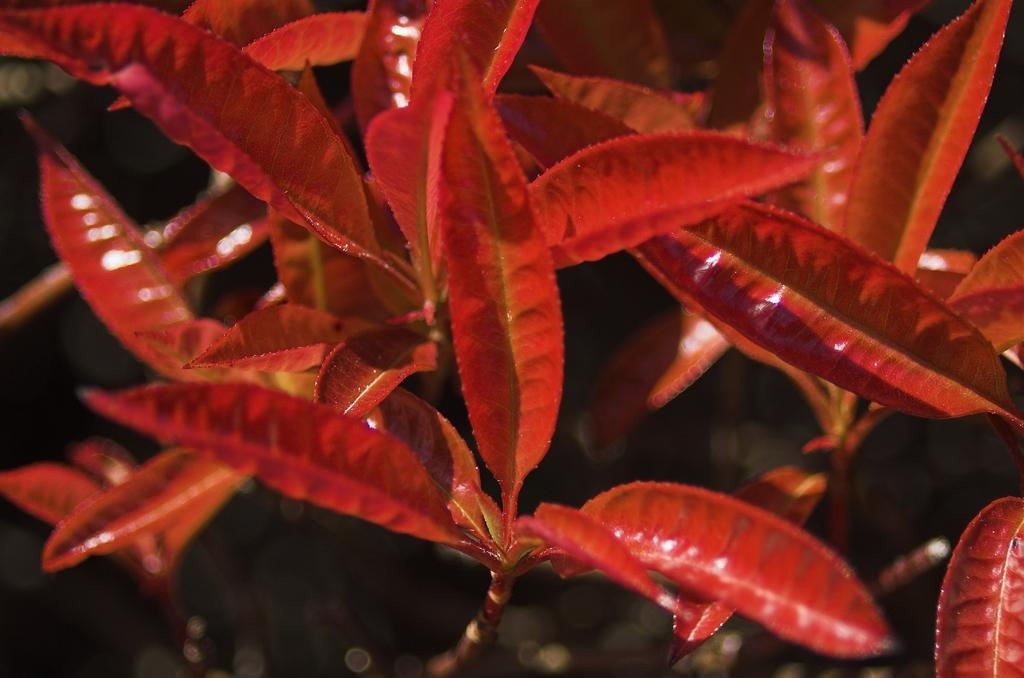What is present in the image? There is a plant in the image. What distinguishing feature can be observed about the plant? The plant has red leaves. What type of sweater is the plant wearing in the image? There is no sweater present in the image, as plants do not wear clothing. 